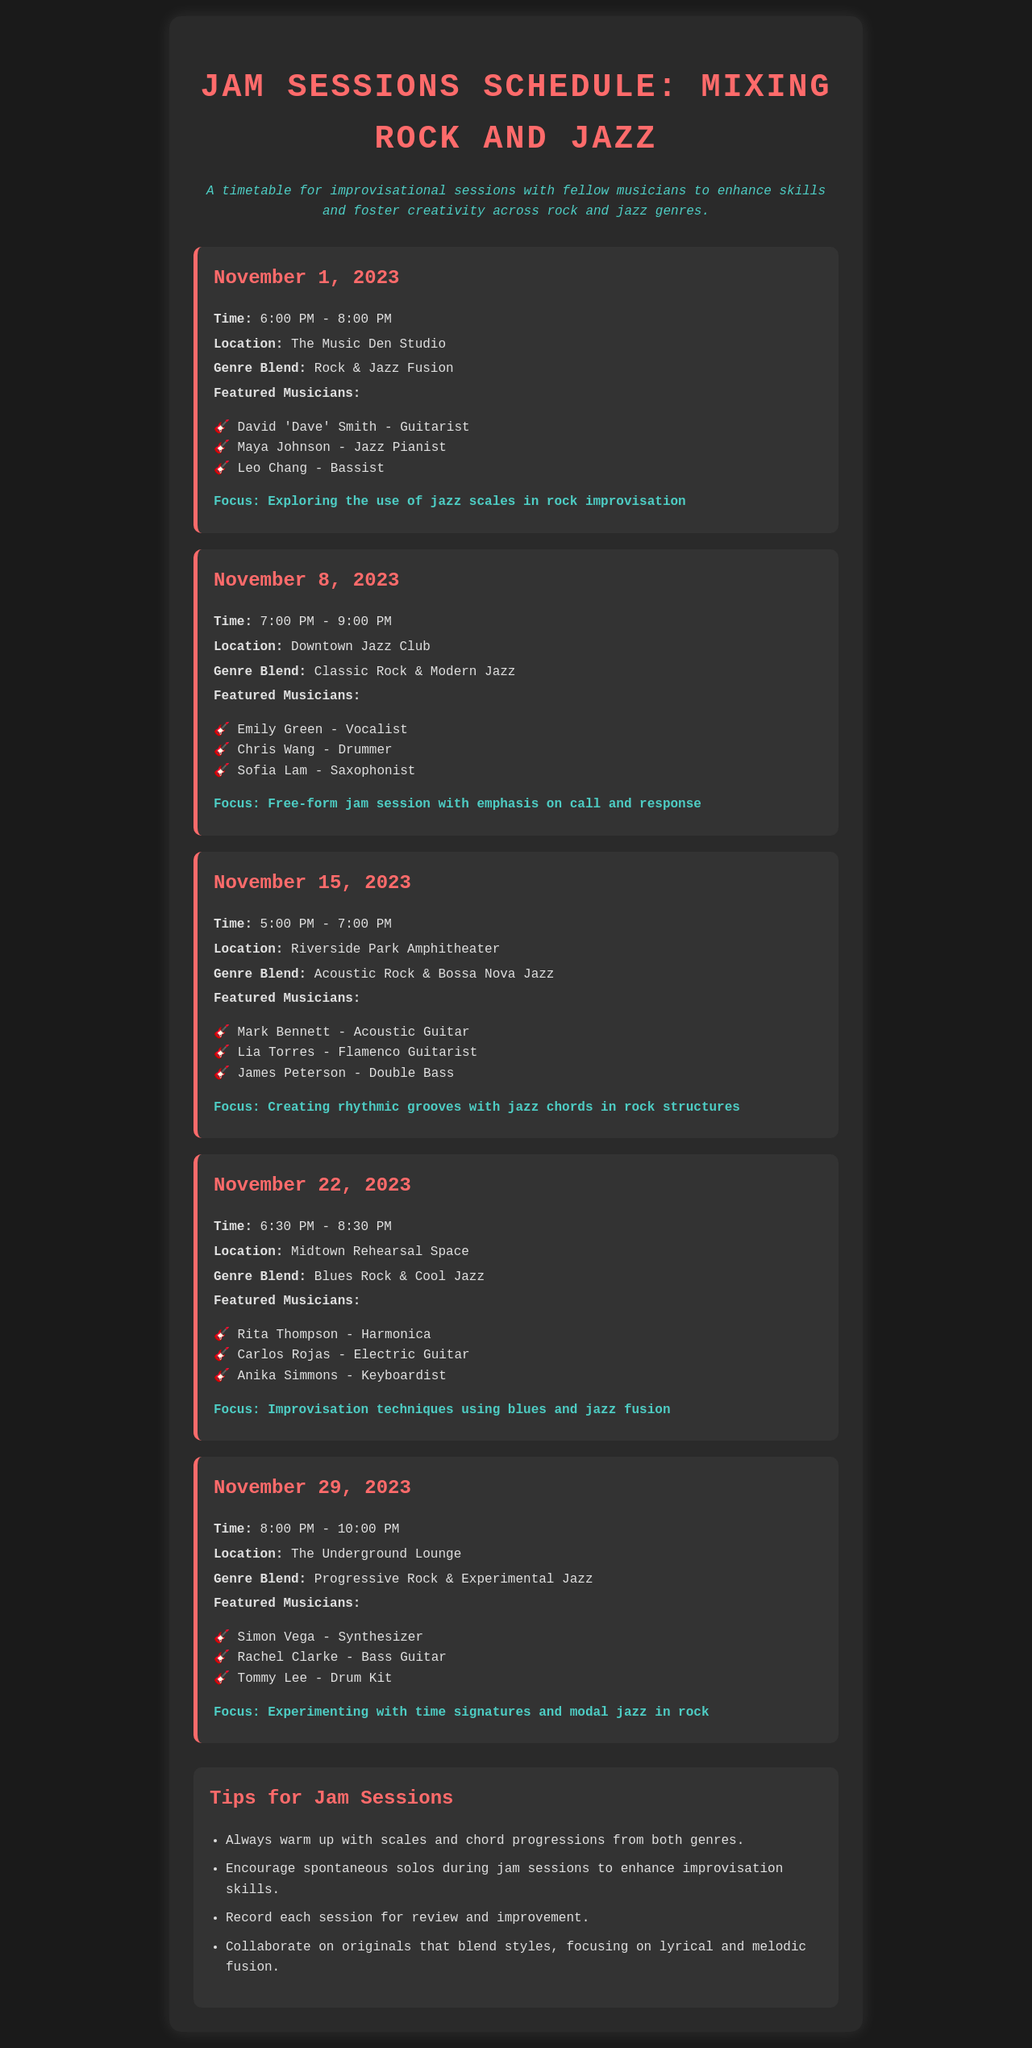What is the date of the first jam session? The first jam session is listed as occurring on November 1, 2023.
Answer: November 1, 2023 What time does the session on November 8 start? The session on November 8 starts at 7:00 PM.
Answer: 7:00 PM Who is the bassist featured on November 1? The document lists Leo Chang as the bassist featured on November 1.
Answer: Leo Chang What is the focus of the November 22 session? The focus of the November 22 session is improvisation techniques using blues and jazz fusion.
Answer: Improvisation techniques using blues and jazz fusion How many musicians are featured in the November 29 session? The November 29 session features three musicians.
Answer: Three What genre blend is highlighted in the November 15 session? The genre blend highlighted in the November 15 session is acoustic rock and bossa nova jazz.
Answer: Acoustic Rock & Bossa Nova Jazz What location hosts the jam session on November 1? The jam session on November 1 is hosted at The Music Den Studio.
Answer: The Music Den Studio Which session focuses on call and response? The session on November 8 focuses on call and response.
Answer: November 8 What is one of the tips provided for jam sessions? One of the tips is to encourage spontaneous solos during jam sessions.
Answer: Encourage spontaneous solos during jam sessions 